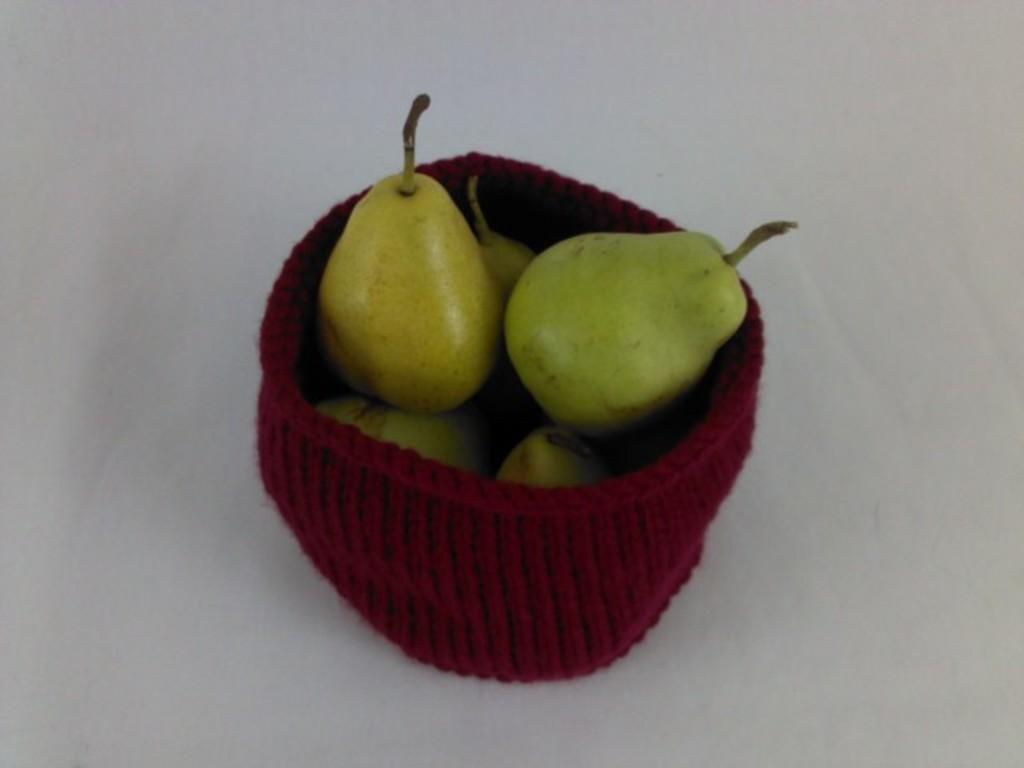What color is the object in the image? The object in the image is red. What is kept inside the red object? There are fruits kept in the red color object. What type of suit can be seen hanging on the wall in the image? There is no suit present in the image; it features a red color object with fruits inside. What color is the ink used for writing in the image? There is no writing or ink present in the image; it only shows a red color object with fruits inside. 